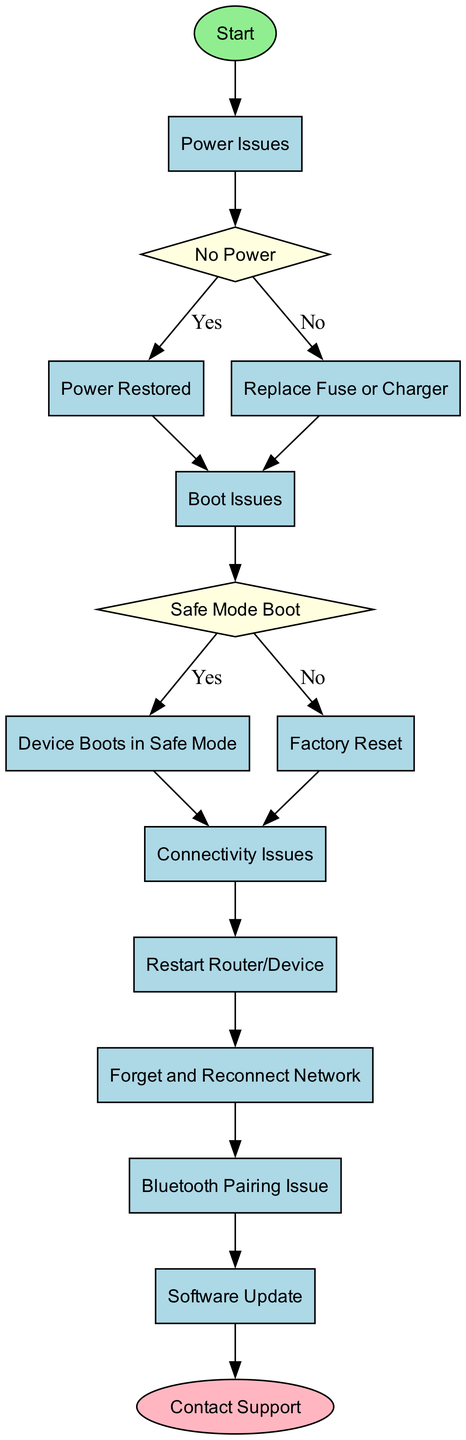What is the title of the diagram? The title of the diagram is explicitly given in the data as "Device Troubleshooting Guide: Common Problems and Solutions."
Answer: Device Troubleshooting Guide: Common Problems and Solutions How many nodes are present in the diagram? By counting all the distinct blocks listed in the data, we find that there are 15 nodes in total.
Answer: 15 What is the first action in the troubleshooting process? The first action is found in the "Start" block, which indicates the initiation of the troubleshooting process.
Answer: Initiate troubleshooting process What action follows "Power Issues"? The action that comes next after "Power Issues" is determined by following the edge from the "Power Issues" block, which points to the decision block "No Power."
Answer: Check if the device is turning on What should you do if the device shows "No Power"? If the decision "No Power" is achieved, the next steps are checked, leading to instructions to ensure that the device is plugged in and the outlet is working.
Answer: Ensure the device is plugged in and the outlet is working If the device does not boot in safe mode, what is the next step? Following the path from "Boot Issues," if the decision for booting in safe mode results in "No," the next step is to perform a factory reset of the device.
Answer: Perform a factory reset How many ways are there to resolve connectivity issues? The "Connectivity Issues" block leads to multiple solutions sequentially described in the diagram: Restart Router/Device, Forget and Reconnect Network, Bluetooth Pairing Issue, and Software Update. This totals four distinct methods to resolve connectivity problems.
Answer: Four What is the final step if all else fails? According to the flow chart, the last action after all troubleshooting steps is to contact the device's customer support for assistance.
Answer: Contact Support What type of block is "Safe Mode Boot"? The "Safe Mode Boot" is classified as a decision block, indicated by its shape in the diagram description, which allows for a yes or no outcome.
Answer: Decision What color is the "Start" block? The color assigned to the "Start" block is light green, which is specified in the diagram's description regarding node coloring for different node types.
Answer: Light green 